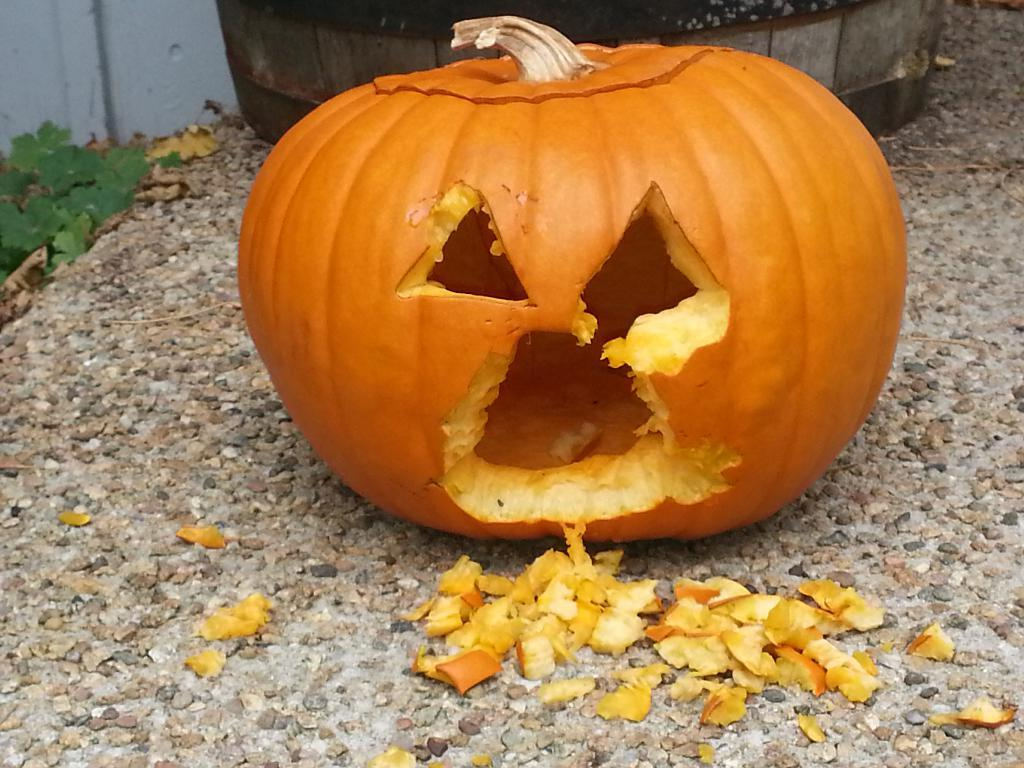What is the main subject of the image? There is a pumpkin in the image. What can be seen on the ground in the image? There are stones on the ground in the image. What is visible in the background of the image? There is an object, leaves, and a wall visible in the background of the image. What type of oatmeal is being served in the image? There is no oatmeal present in the image. What is the purpose of the bucket in the image? There is no bucket present in the image. 